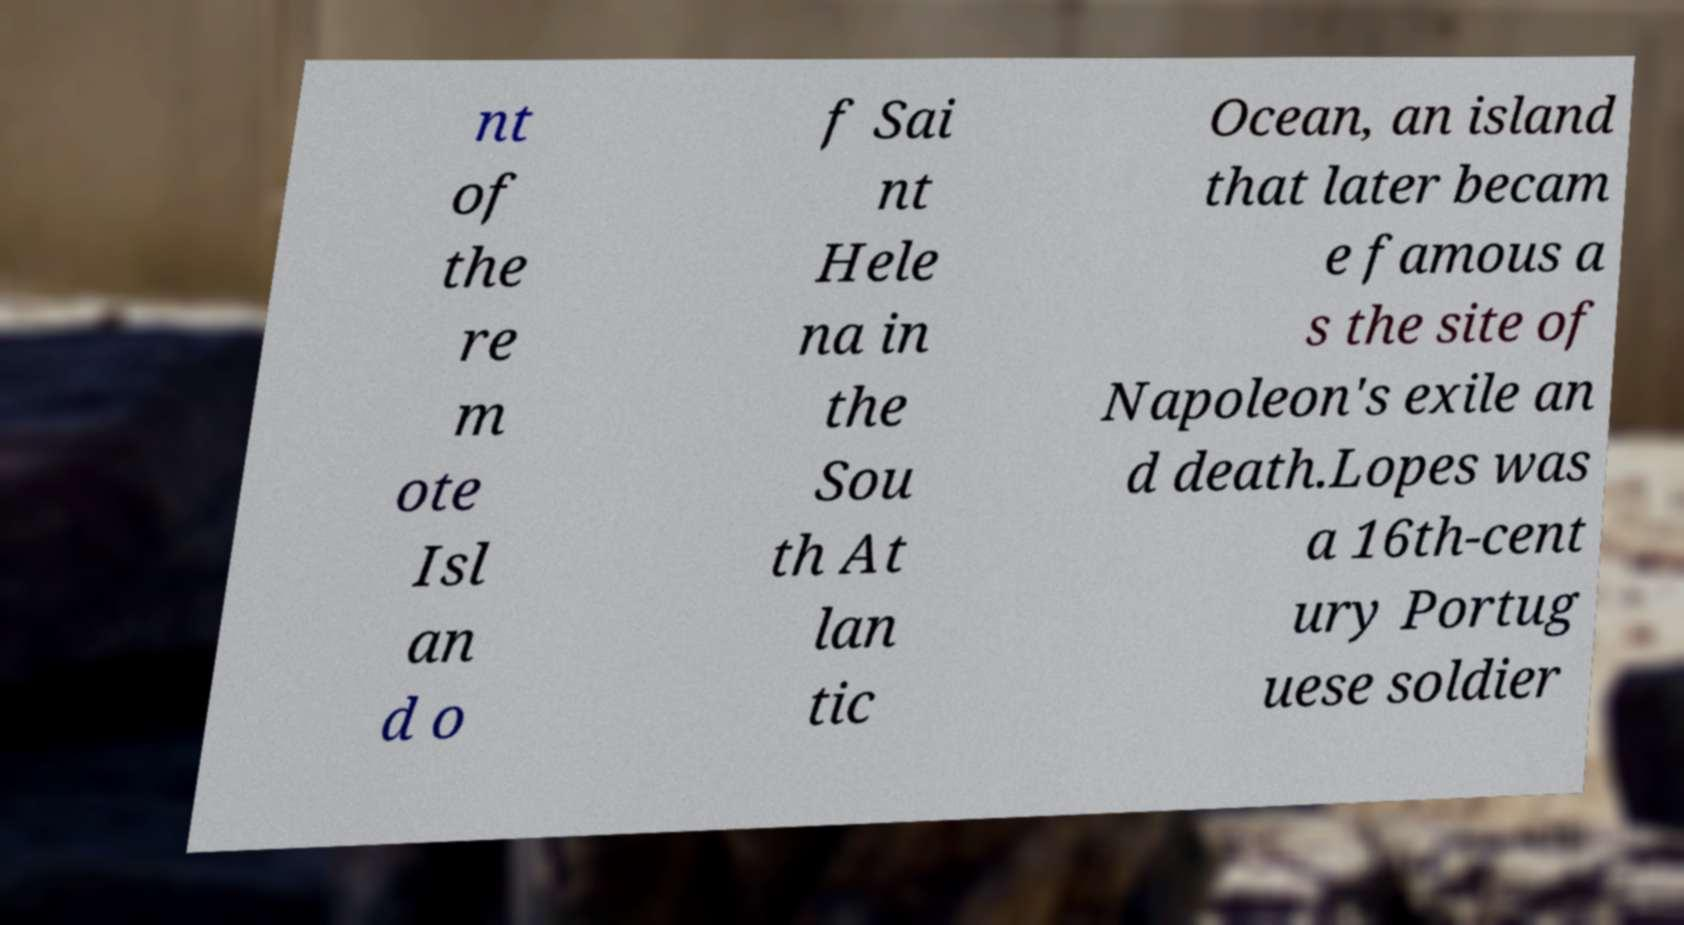What messages or text are displayed in this image? I need them in a readable, typed format. nt of the re m ote Isl an d o f Sai nt Hele na in the Sou th At lan tic Ocean, an island that later becam e famous a s the site of Napoleon's exile an d death.Lopes was a 16th-cent ury Portug uese soldier 